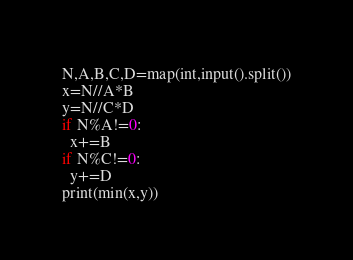Convert code to text. <code><loc_0><loc_0><loc_500><loc_500><_Python_>N,A,B,C,D=map(int,input().split())
x=N//A*B
y=N//C*D
if N%A!=0:
  x+=B
if N%C!=0:
  y+=D
print(min(x,y))
</code> 